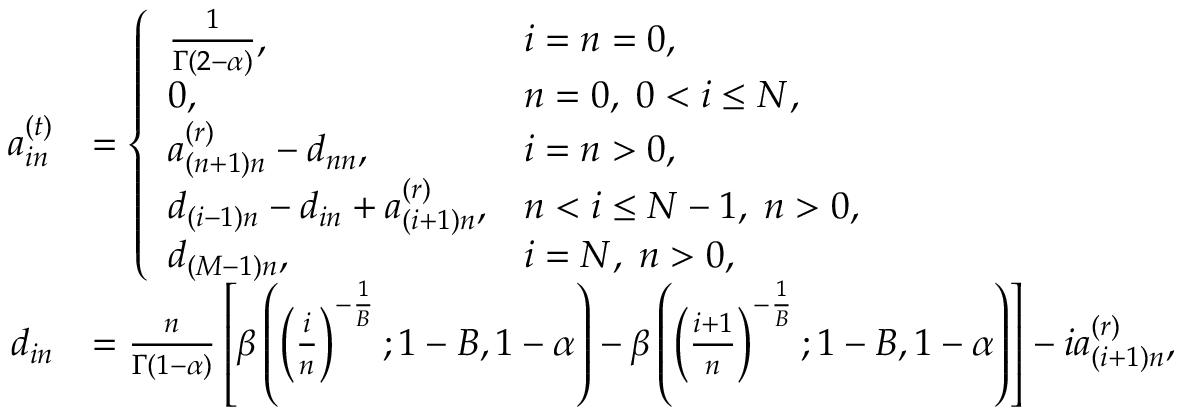Convert formula to latex. <formula><loc_0><loc_0><loc_500><loc_500>\begin{array} { r l } { a _ { i n } ^ { ( t ) } } & { = \left \{ \begin{array} { l l } { \frac { 1 } { \Gamma ( 2 - \alpha ) } , } & { i = n = 0 , } \\ { 0 , } & { n = 0 , \, 0 < i \leq N , } \\ { a _ { ( n + 1 ) n } ^ { ( r ) } - d _ { n n } , } & { i = n > 0 , } \\ { d _ { ( i - 1 ) n } - d _ { i n } + a _ { ( i + 1 ) n } ^ { ( r ) } , } & { n < i \leq N - 1 , \, n > 0 , } \\ { d _ { ( M - 1 ) n } , } & { i = N , \, n > 0 , } \end{array} } \\ { d _ { i n } } & { = \frac { n } { \Gamma ( 1 - \alpha ) } \left [ \beta \left ( \left ( \frac { i } { n } \right ) ^ { - \frac { 1 } { B } } ; 1 - B , 1 - \alpha \right ) - \beta \left ( \left ( \frac { i + 1 } { n } \right ) ^ { - \frac { 1 } { B } } ; 1 - B , 1 - \alpha \right ) \right ] - i a _ { ( i + 1 ) n } ^ { ( r ) } , } \end{array}</formula> 